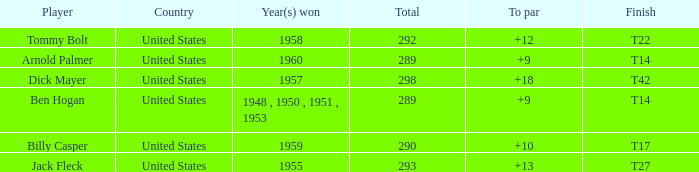What is the total number of Total, when To Par is 12? 1.0. 